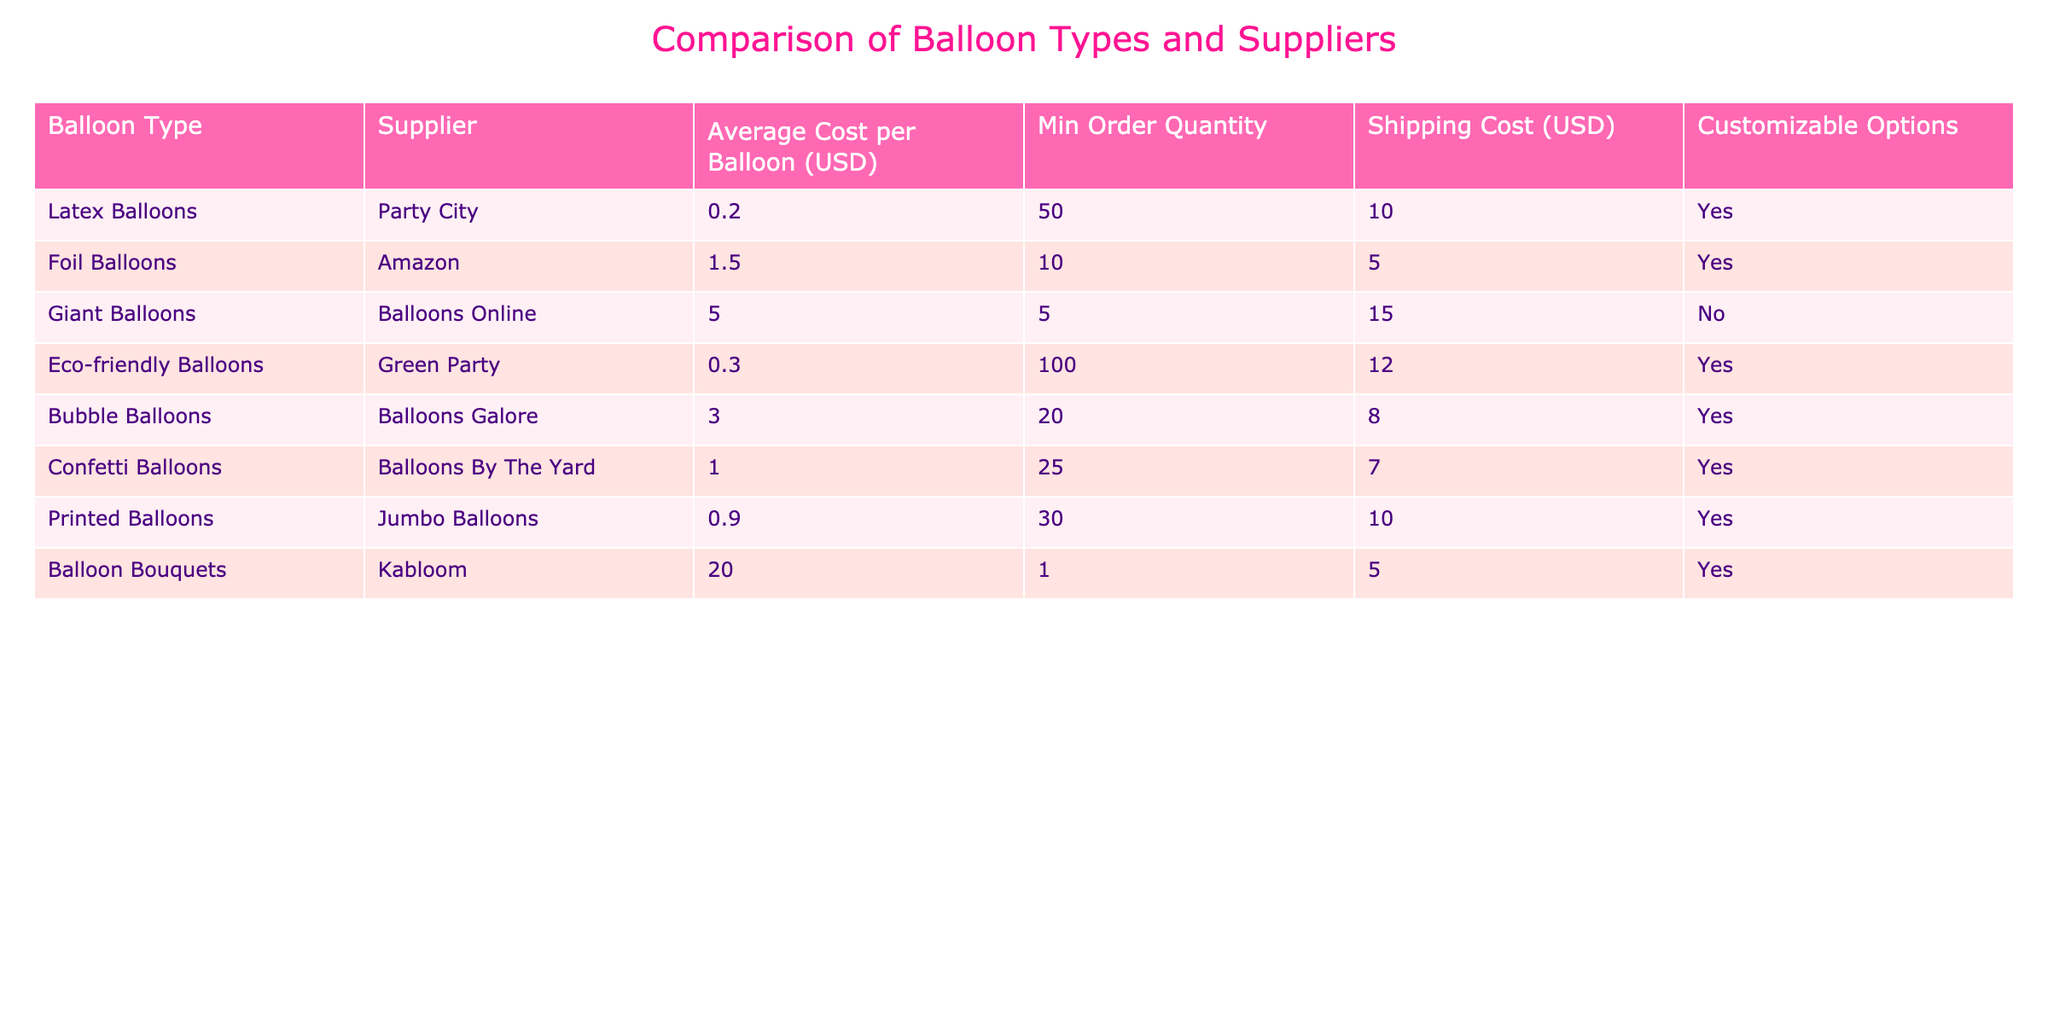What is the average cost of a latex balloon? The average cost of a latex balloon from Party City is listed as 0.20 USD.
Answer: 0.20 USD Which balloon type has the highest average cost per balloon? The balloon type with the highest average cost is Balloon Bouquets, which cost 20.00 USD each.
Answer: Balloon Bouquets Are bubble balloons customizable? Yes, bubble balloons have customizable options available according to the table.
Answer: Yes What is the total cost for ordering 50 latex balloons, including shipping? To find the total cost, first calculate the cost of 50 latex balloons, which is 50 * 0.20 = 10.00 USD. The shipping cost is 10.00 USD. Therefore, the total cost is 10.00 + 10.00 = 20.00 USD.
Answer: 20.00 USD How many suppliers offer customizable options? Looking at the table, the suppliers that offer customizable options are Party City, Amazon, Green Party, Balloons Galore, Balloons By The Yard, Jumbo Balloons, and Kabloom. This totals to 7 suppliers.
Answer: 7 suppliers If I order 30 printed balloons and want to include shipping, what will the total cost be? The cost for 30 printed balloons is 30 * 0.90 = 27.00 USD. The shipping cost for printed balloons is 10.00 USD. Therefore, the total cost is 27.00 + 10.00 = 37.00 USD.
Answer: 37.00 USD What is the minimum order quantity for eco-friendly balloons? According to the table, the minimum order quantity for eco-friendly balloons from Green Party is 100.
Answer: 100 Do any suppliers offer giant balloons with customizable options? No, the table indicates that giant balloons from Balloons Online do not have customizable options available.
Answer: No 